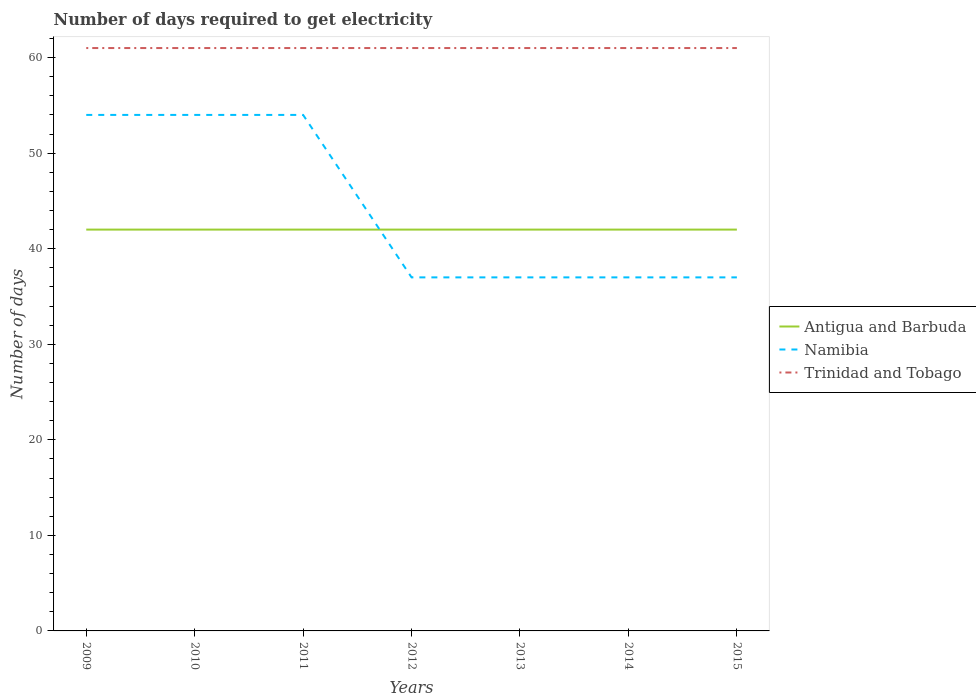Does the line corresponding to Namibia intersect with the line corresponding to Trinidad and Tobago?
Your answer should be compact. No. Is the number of lines equal to the number of legend labels?
Keep it short and to the point. Yes. Across all years, what is the maximum number of days required to get electricity in in Trinidad and Tobago?
Make the answer very short. 61. What is the total number of days required to get electricity in in Antigua and Barbuda in the graph?
Offer a terse response. 0. What is the difference between the highest and the lowest number of days required to get electricity in in Trinidad and Tobago?
Offer a terse response. 0. Is the number of days required to get electricity in in Antigua and Barbuda strictly greater than the number of days required to get electricity in in Trinidad and Tobago over the years?
Your answer should be very brief. Yes. How many years are there in the graph?
Your answer should be very brief. 7. What is the difference between two consecutive major ticks on the Y-axis?
Your answer should be very brief. 10. Are the values on the major ticks of Y-axis written in scientific E-notation?
Provide a succinct answer. No. Does the graph contain any zero values?
Your response must be concise. No. What is the title of the graph?
Your response must be concise. Number of days required to get electricity. What is the label or title of the X-axis?
Provide a short and direct response. Years. What is the label or title of the Y-axis?
Your answer should be very brief. Number of days. What is the Number of days in Namibia in 2009?
Give a very brief answer. 54. What is the Number of days of Namibia in 2010?
Provide a short and direct response. 54. What is the Number of days of Trinidad and Tobago in 2010?
Your response must be concise. 61. What is the Number of days in Antigua and Barbuda in 2011?
Ensure brevity in your answer.  42. What is the Number of days in Namibia in 2011?
Ensure brevity in your answer.  54. What is the Number of days in Namibia in 2012?
Keep it short and to the point. 37. What is the Number of days in Trinidad and Tobago in 2012?
Give a very brief answer. 61. What is the Number of days in Namibia in 2013?
Keep it short and to the point. 37. What is the Number of days of Namibia in 2014?
Keep it short and to the point. 37. What is the Number of days of Trinidad and Tobago in 2014?
Provide a succinct answer. 61. Across all years, what is the maximum Number of days in Antigua and Barbuda?
Provide a succinct answer. 42. Across all years, what is the maximum Number of days of Namibia?
Your answer should be compact. 54. Across all years, what is the maximum Number of days of Trinidad and Tobago?
Your answer should be very brief. 61. Across all years, what is the minimum Number of days of Namibia?
Ensure brevity in your answer.  37. Across all years, what is the minimum Number of days of Trinidad and Tobago?
Provide a short and direct response. 61. What is the total Number of days of Antigua and Barbuda in the graph?
Provide a succinct answer. 294. What is the total Number of days of Namibia in the graph?
Ensure brevity in your answer.  310. What is the total Number of days of Trinidad and Tobago in the graph?
Your answer should be very brief. 427. What is the difference between the Number of days in Namibia in 2009 and that in 2010?
Provide a succinct answer. 0. What is the difference between the Number of days of Namibia in 2009 and that in 2012?
Provide a short and direct response. 17. What is the difference between the Number of days of Trinidad and Tobago in 2009 and that in 2012?
Offer a very short reply. 0. What is the difference between the Number of days in Antigua and Barbuda in 2009 and that in 2013?
Your answer should be compact. 0. What is the difference between the Number of days in Trinidad and Tobago in 2009 and that in 2013?
Keep it short and to the point. 0. What is the difference between the Number of days in Antigua and Barbuda in 2009 and that in 2014?
Your answer should be compact. 0. What is the difference between the Number of days in Namibia in 2009 and that in 2014?
Make the answer very short. 17. What is the difference between the Number of days in Trinidad and Tobago in 2009 and that in 2014?
Ensure brevity in your answer.  0. What is the difference between the Number of days in Antigua and Barbuda in 2009 and that in 2015?
Ensure brevity in your answer.  0. What is the difference between the Number of days in Antigua and Barbuda in 2010 and that in 2011?
Your response must be concise. 0. What is the difference between the Number of days of Trinidad and Tobago in 2010 and that in 2011?
Provide a short and direct response. 0. What is the difference between the Number of days of Antigua and Barbuda in 2010 and that in 2012?
Provide a short and direct response. 0. What is the difference between the Number of days of Namibia in 2010 and that in 2012?
Keep it short and to the point. 17. What is the difference between the Number of days in Trinidad and Tobago in 2010 and that in 2012?
Make the answer very short. 0. What is the difference between the Number of days of Namibia in 2010 and that in 2013?
Offer a very short reply. 17. What is the difference between the Number of days in Antigua and Barbuda in 2010 and that in 2015?
Give a very brief answer. 0. What is the difference between the Number of days in Namibia in 2011 and that in 2012?
Offer a terse response. 17. What is the difference between the Number of days in Trinidad and Tobago in 2011 and that in 2012?
Give a very brief answer. 0. What is the difference between the Number of days of Namibia in 2011 and that in 2013?
Offer a terse response. 17. What is the difference between the Number of days of Namibia in 2011 and that in 2015?
Offer a very short reply. 17. What is the difference between the Number of days in Trinidad and Tobago in 2011 and that in 2015?
Provide a short and direct response. 0. What is the difference between the Number of days in Namibia in 2012 and that in 2013?
Offer a terse response. 0. What is the difference between the Number of days in Trinidad and Tobago in 2012 and that in 2013?
Your answer should be very brief. 0. What is the difference between the Number of days of Antigua and Barbuda in 2012 and that in 2014?
Provide a short and direct response. 0. What is the difference between the Number of days in Namibia in 2012 and that in 2014?
Ensure brevity in your answer.  0. What is the difference between the Number of days of Antigua and Barbuda in 2013 and that in 2014?
Offer a terse response. 0. What is the difference between the Number of days of Trinidad and Tobago in 2013 and that in 2014?
Ensure brevity in your answer.  0. What is the difference between the Number of days in Namibia in 2013 and that in 2015?
Provide a short and direct response. 0. What is the difference between the Number of days in Namibia in 2014 and that in 2015?
Ensure brevity in your answer.  0. What is the difference between the Number of days of Trinidad and Tobago in 2014 and that in 2015?
Offer a terse response. 0. What is the difference between the Number of days of Antigua and Barbuda in 2009 and the Number of days of Namibia in 2010?
Offer a terse response. -12. What is the difference between the Number of days in Namibia in 2009 and the Number of days in Trinidad and Tobago in 2010?
Your response must be concise. -7. What is the difference between the Number of days of Namibia in 2009 and the Number of days of Trinidad and Tobago in 2011?
Your response must be concise. -7. What is the difference between the Number of days of Antigua and Barbuda in 2009 and the Number of days of Namibia in 2012?
Provide a short and direct response. 5. What is the difference between the Number of days of Antigua and Barbuda in 2009 and the Number of days of Trinidad and Tobago in 2012?
Keep it short and to the point. -19. What is the difference between the Number of days in Namibia in 2009 and the Number of days in Trinidad and Tobago in 2012?
Provide a short and direct response. -7. What is the difference between the Number of days in Antigua and Barbuda in 2009 and the Number of days in Namibia in 2013?
Give a very brief answer. 5. What is the difference between the Number of days of Namibia in 2009 and the Number of days of Trinidad and Tobago in 2013?
Give a very brief answer. -7. What is the difference between the Number of days in Namibia in 2009 and the Number of days in Trinidad and Tobago in 2014?
Keep it short and to the point. -7. What is the difference between the Number of days in Antigua and Barbuda in 2009 and the Number of days in Trinidad and Tobago in 2015?
Offer a terse response. -19. What is the difference between the Number of days of Namibia in 2009 and the Number of days of Trinidad and Tobago in 2015?
Your answer should be very brief. -7. What is the difference between the Number of days in Antigua and Barbuda in 2010 and the Number of days in Trinidad and Tobago in 2011?
Your response must be concise. -19. What is the difference between the Number of days in Antigua and Barbuda in 2010 and the Number of days in Namibia in 2012?
Ensure brevity in your answer.  5. What is the difference between the Number of days of Antigua and Barbuda in 2010 and the Number of days of Namibia in 2013?
Provide a short and direct response. 5. What is the difference between the Number of days in Antigua and Barbuda in 2010 and the Number of days in Trinidad and Tobago in 2013?
Make the answer very short. -19. What is the difference between the Number of days of Antigua and Barbuda in 2010 and the Number of days of Namibia in 2014?
Provide a succinct answer. 5. What is the difference between the Number of days of Antigua and Barbuda in 2010 and the Number of days of Trinidad and Tobago in 2014?
Your answer should be compact. -19. What is the difference between the Number of days of Namibia in 2010 and the Number of days of Trinidad and Tobago in 2014?
Provide a short and direct response. -7. What is the difference between the Number of days of Antigua and Barbuda in 2010 and the Number of days of Namibia in 2015?
Provide a succinct answer. 5. What is the difference between the Number of days in Antigua and Barbuda in 2010 and the Number of days in Trinidad and Tobago in 2015?
Your answer should be compact. -19. What is the difference between the Number of days of Antigua and Barbuda in 2011 and the Number of days of Namibia in 2012?
Keep it short and to the point. 5. What is the difference between the Number of days of Antigua and Barbuda in 2011 and the Number of days of Trinidad and Tobago in 2012?
Provide a succinct answer. -19. What is the difference between the Number of days of Namibia in 2011 and the Number of days of Trinidad and Tobago in 2012?
Ensure brevity in your answer.  -7. What is the difference between the Number of days of Antigua and Barbuda in 2011 and the Number of days of Namibia in 2013?
Give a very brief answer. 5. What is the difference between the Number of days in Antigua and Barbuda in 2011 and the Number of days in Trinidad and Tobago in 2013?
Keep it short and to the point. -19. What is the difference between the Number of days of Namibia in 2011 and the Number of days of Trinidad and Tobago in 2013?
Provide a short and direct response. -7. What is the difference between the Number of days of Antigua and Barbuda in 2011 and the Number of days of Namibia in 2014?
Your answer should be compact. 5. What is the difference between the Number of days in Antigua and Barbuda in 2011 and the Number of days in Trinidad and Tobago in 2015?
Your answer should be very brief. -19. What is the difference between the Number of days of Antigua and Barbuda in 2012 and the Number of days of Namibia in 2013?
Make the answer very short. 5. What is the difference between the Number of days in Antigua and Barbuda in 2012 and the Number of days in Trinidad and Tobago in 2013?
Offer a very short reply. -19. What is the difference between the Number of days of Namibia in 2012 and the Number of days of Trinidad and Tobago in 2013?
Offer a very short reply. -24. What is the difference between the Number of days in Namibia in 2012 and the Number of days in Trinidad and Tobago in 2014?
Your answer should be compact. -24. What is the difference between the Number of days in Antigua and Barbuda in 2013 and the Number of days in Namibia in 2014?
Provide a succinct answer. 5. What is the difference between the Number of days of Antigua and Barbuda in 2013 and the Number of days of Trinidad and Tobago in 2014?
Your answer should be very brief. -19. What is the difference between the Number of days of Namibia in 2013 and the Number of days of Trinidad and Tobago in 2014?
Provide a succinct answer. -24. What is the difference between the Number of days of Antigua and Barbuda in 2013 and the Number of days of Namibia in 2015?
Make the answer very short. 5. What is the difference between the Number of days in Antigua and Barbuda in 2013 and the Number of days in Trinidad and Tobago in 2015?
Provide a short and direct response. -19. What is the difference between the Number of days of Namibia in 2013 and the Number of days of Trinidad and Tobago in 2015?
Your answer should be very brief. -24. What is the difference between the Number of days in Antigua and Barbuda in 2014 and the Number of days in Namibia in 2015?
Give a very brief answer. 5. What is the difference between the Number of days in Namibia in 2014 and the Number of days in Trinidad and Tobago in 2015?
Provide a succinct answer. -24. What is the average Number of days of Namibia per year?
Make the answer very short. 44.29. What is the average Number of days of Trinidad and Tobago per year?
Give a very brief answer. 61. In the year 2010, what is the difference between the Number of days of Antigua and Barbuda and Number of days of Namibia?
Give a very brief answer. -12. In the year 2010, what is the difference between the Number of days in Antigua and Barbuda and Number of days in Trinidad and Tobago?
Your response must be concise. -19. In the year 2010, what is the difference between the Number of days in Namibia and Number of days in Trinidad and Tobago?
Ensure brevity in your answer.  -7. In the year 2011, what is the difference between the Number of days in Antigua and Barbuda and Number of days in Namibia?
Provide a succinct answer. -12. In the year 2011, what is the difference between the Number of days of Antigua and Barbuda and Number of days of Trinidad and Tobago?
Your answer should be compact. -19. In the year 2012, what is the difference between the Number of days in Antigua and Barbuda and Number of days in Namibia?
Give a very brief answer. 5. In the year 2012, what is the difference between the Number of days of Antigua and Barbuda and Number of days of Trinidad and Tobago?
Keep it short and to the point. -19. In the year 2012, what is the difference between the Number of days in Namibia and Number of days in Trinidad and Tobago?
Your response must be concise. -24. In the year 2013, what is the difference between the Number of days in Antigua and Barbuda and Number of days in Trinidad and Tobago?
Provide a short and direct response. -19. In the year 2014, what is the difference between the Number of days in Namibia and Number of days in Trinidad and Tobago?
Ensure brevity in your answer.  -24. In the year 2015, what is the difference between the Number of days of Antigua and Barbuda and Number of days of Namibia?
Keep it short and to the point. 5. In the year 2015, what is the difference between the Number of days of Antigua and Barbuda and Number of days of Trinidad and Tobago?
Ensure brevity in your answer.  -19. In the year 2015, what is the difference between the Number of days in Namibia and Number of days in Trinidad and Tobago?
Offer a very short reply. -24. What is the ratio of the Number of days of Namibia in 2009 to that in 2010?
Ensure brevity in your answer.  1. What is the ratio of the Number of days in Trinidad and Tobago in 2009 to that in 2010?
Provide a succinct answer. 1. What is the ratio of the Number of days in Antigua and Barbuda in 2009 to that in 2011?
Provide a succinct answer. 1. What is the ratio of the Number of days in Namibia in 2009 to that in 2011?
Your answer should be very brief. 1. What is the ratio of the Number of days of Antigua and Barbuda in 2009 to that in 2012?
Offer a terse response. 1. What is the ratio of the Number of days in Namibia in 2009 to that in 2012?
Make the answer very short. 1.46. What is the ratio of the Number of days of Trinidad and Tobago in 2009 to that in 2012?
Keep it short and to the point. 1. What is the ratio of the Number of days of Namibia in 2009 to that in 2013?
Ensure brevity in your answer.  1.46. What is the ratio of the Number of days in Trinidad and Tobago in 2009 to that in 2013?
Your answer should be very brief. 1. What is the ratio of the Number of days of Namibia in 2009 to that in 2014?
Provide a short and direct response. 1.46. What is the ratio of the Number of days of Antigua and Barbuda in 2009 to that in 2015?
Keep it short and to the point. 1. What is the ratio of the Number of days of Namibia in 2009 to that in 2015?
Your answer should be compact. 1.46. What is the ratio of the Number of days of Trinidad and Tobago in 2010 to that in 2011?
Keep it short and to the point. 1. What is the ratio of the Number of days of Antigua and Barbuda in 2010 to that in 2012?
Provide a short and direct response. 1. What is the ratio of the Number of days of Namibia in 2010 to that in 2012?
Your response must be concise. 1.46. What is the ratio of the Number of days of Trinidad and Tobago in 2010 to that in 2012?
Provide a short and direct response. 1. What is the ratio of the Number of days in Antigua and Barbuda in 2010 to that in 2013?
Provide a short and direct response. 1. What is the ratio of the Number of days of Namibia in 2010 to that in 2013?
Keep it short and to the point. 1.46. What is the ratio of the Number of days in Antigua and Barbuda in 2010 to that in 2014?
Provide a short and direct response. 1. What is the ratio of the Number of days of Namibia in 2010 to that in 2014?
Provide a short and direct response. 1.46. What is the ratio of the Number of days in Antigua and Barbuda in 2010 to that in 2015?
Keep it short and to the point. 1. What is the ratio of the Number of days of Namibia in 2010 to that in 2015?
Offer a very short reply. 1.46. What is the ratio of the Number of days in Namibia in 2011 to that in 2012?
Offer a terse response. 1.46. What is the ratio of the Number of days in Trinidad and Tobago in 2011 to that in 2012?
Offer a terse response. 1. What is the ratio of the Number of days of Namibia in 2011 to that in 2013?
Provide a short and direct response. 1.46. What is the ratio of the Number of days of Namibia in 2011 to that in 2014?
Make the answer very short. 1.46. What is the ratio of the Number of days in Trinidad and Tobago in 2011 to that in 2014?
Your answer should be compact. 1. What is the ratio of the Number of days of Antigua and Barbuda in 2011 to that in 2015?
Your answer should be very brief. 1. What is the ratio of the Number of days in Namibia in 2011 to that in 2015?
Offer a terse response. 1.46. What is the ratio of the Number of days of Trinidad and Tobago in 2011 to that in 2015?
Your response must be concise. 1. What is the ratio of the Number of days of Antigua and Barbuda in 2012 to that in 2013?
Ensure brevity in your answer.  1. What is the ratio of the Number of days of Antigua and Barbuda in 2012 to that in 2014?
Provide a short and direct response. 1. What is the ratio of the Number of days of Namibia in 2012 to that in 2014?
Your answer should be very brief. 1. What is the ratio of the Number of days of Trinidad and Tobago in 2012 to that in 2015?
Provide a short and direct response. 1. What is the ratio of the Number of days of Antigua and Barbuda in 2013 to that in 2014?
Provide a short and direct response. 1. What is the ratio of the Number of days in Trinidad and Tobago in 2013 to that in 2015?
Keep it short and to the point. 1. What is the ratio of the Number of days of Antigua and Barbuda in 2014 to that in 2015?
Your answer should be compact. 1. What is the ratio of the Number of days of Namibia in 2014 to that in 2015?
Provide a succinct answer. 1. What is the ratio of the Number of days of Trinidad and Tobago in 2014 to that in 2015?
Make the answer very short. 1. What is the difference between the highest and the second highest Number of days in Antigua and Barbuda?
Ensure brevity in your answer.  0. What is the difference between the highest and the second highest Number of days in Namibia?
Your answer should be compact. 0. What is the difference between the highest and the second highest Number of days in Trinidad and Tobago?
Your answer should be very brief. 0. What is the difference between the highest and the lowest Number of days of Antigua and Barbuda?
Provide a succinct answer. 0. 